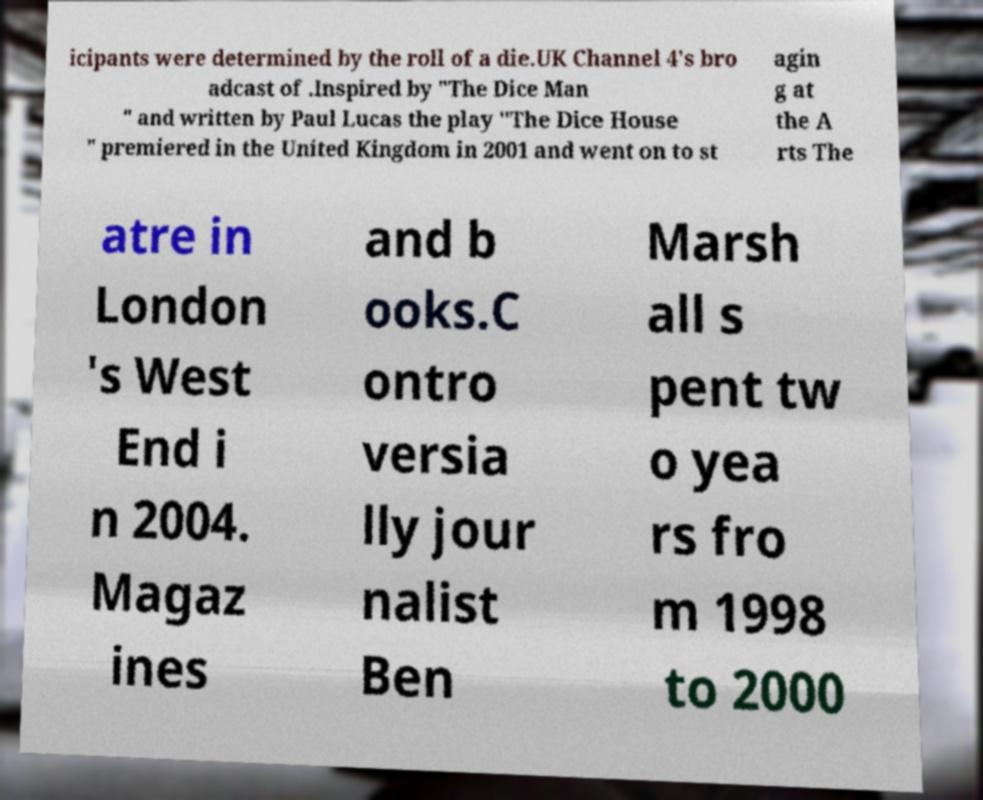There's text embedded in this image that I need extracted. Can you transcribe it verbatim? icipants were determined by the roll of a die.UK Channel 4's bro adcast of .Inspired by "The Dice Man " and written by Paul Lucas the play "The Dice House " premiered in the United Kingdom in 2001 and went on to st agin g at the A rts The atre in London 's West End i n 2004. Magaz ines and b ooks.C ontro versia lly jour nalist Ben Marsh all s pent tw o yea rs fro m 1998 to 2000 